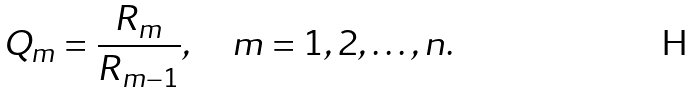Convert formula to latex. <formula><loc_0><loc_0><loc_500><loc_500>Q _ { m } = \frac { R _ { m } } { R _ { m - 1 } } , \quad m = 1 , 2 , \dots , n .</formula> 